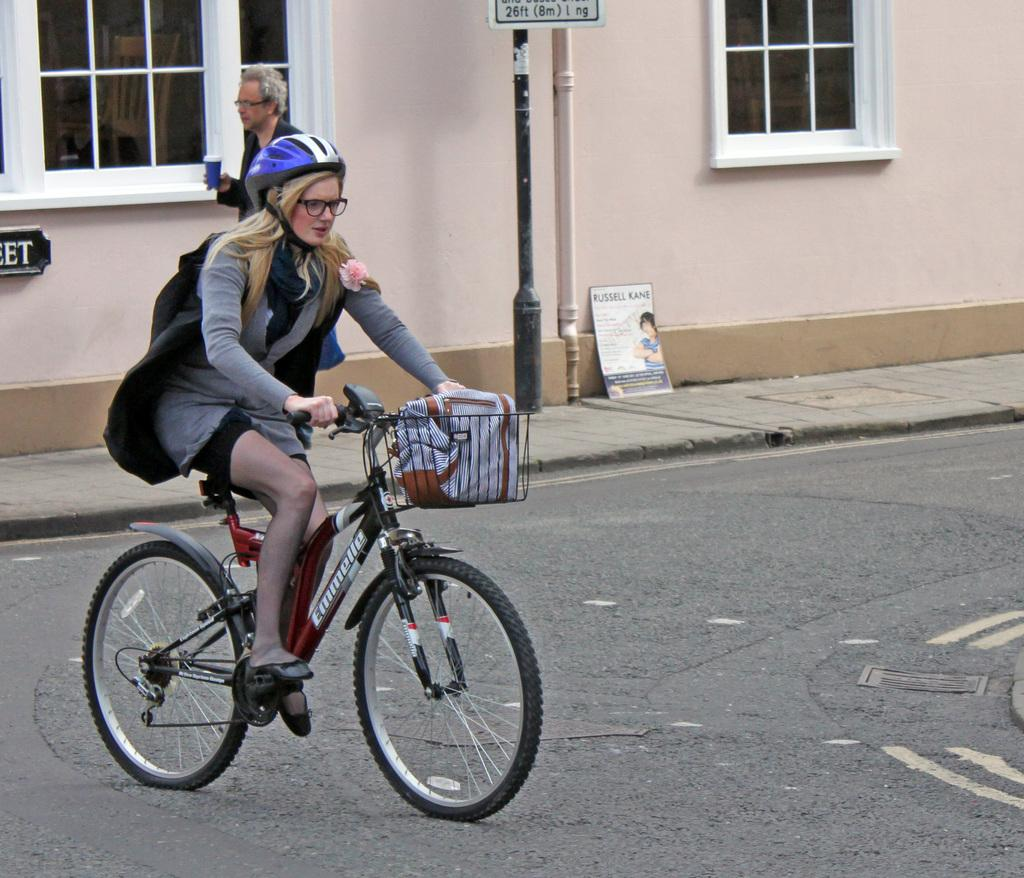Who is the main subject in the image? There is a woman in the image. What is the woman doing in the image? The woman is cycling a cycle. Can you describe the background of the image? There is a man in the background of the image. What is the man holding in the image? The man is holding a cup. Where is the faucet located in the image? There is no faucet present in the image. In which direction is the woman cycling in the image? The direction in which the woman is cycling cannot be determined from the image alone. 